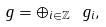<formula> <loc_0><loc_0><loc_500><loc_500>\ g = \oplus _ { i \in \mathbb { Z } } \ g _ { i } ,</formula> 